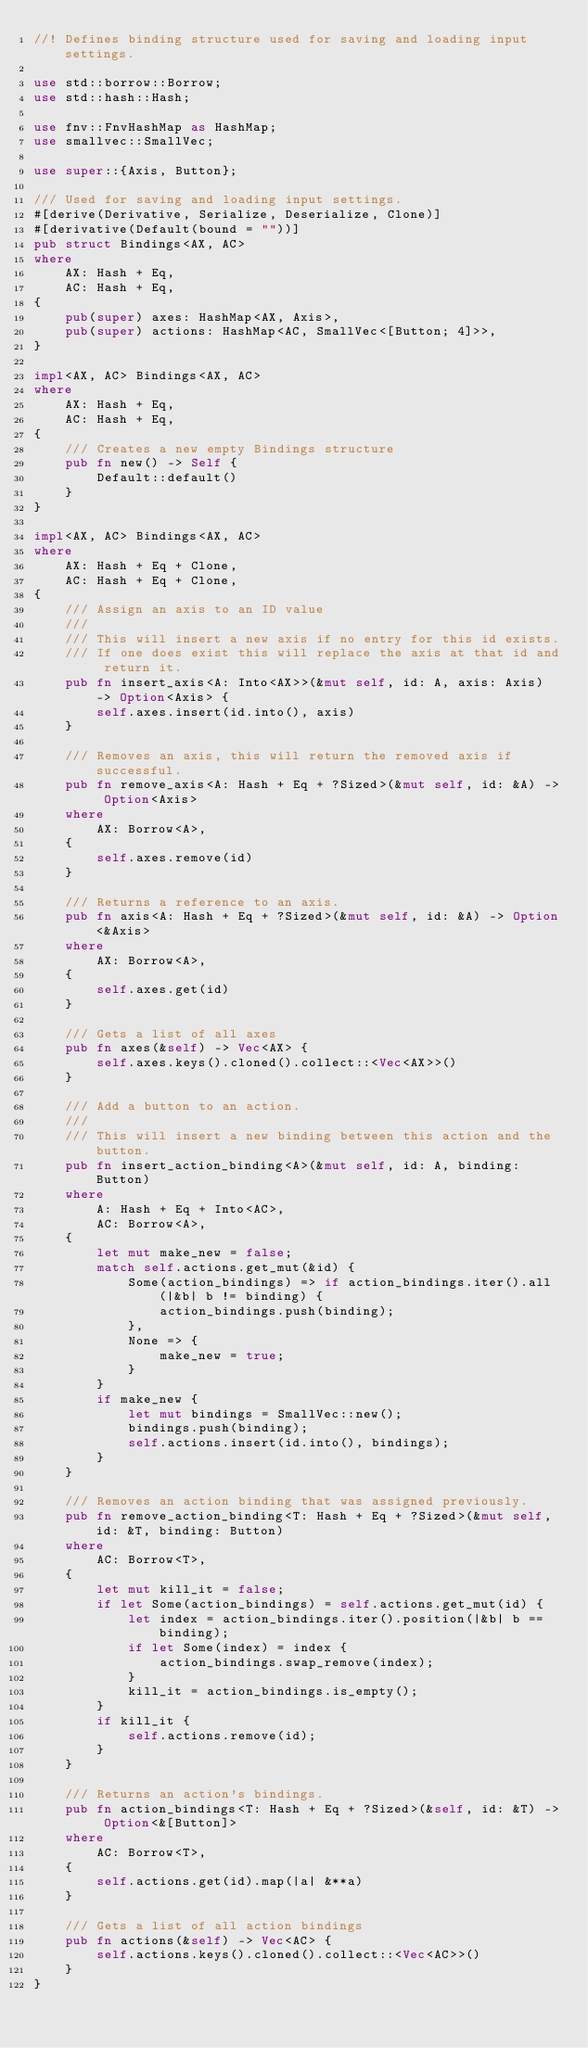Convert code to text. <code><loc_0><loc_0><loc_500><loc_500><_Rust_>//! Defines binding structure used for saving and loading input settings.

use std::borrow::Borrow;
use std::hash::Hash;

use fnv::FnvHashMap as HashMap;
use smallvec::SmallVec;

use super::{Axis, Button};

/// Used for saving and loading input settings.
#[derive(Derivative, Serialize, Deserialize, Clone)]
#[derivative(Default(bound = ""))]
pub struct Bindings<AX, AC>
where
    AX: Hash + Eq,
    AC: Hash + Eq,
{
    pub(super) axes: HashMap<AX, Axis>,
    pub(super) actions: HashMap<AC, SmallVec<[Button; 4]>>,
}

impl<AX, AC> Bindings<AX, AC>
where
    AX: Hash + Eq,
    AC: Hash + Eq,
{
    /// Creates a new empty Bindings structure
    pub fn new() -> Self {
        Default::default()
    }
}

impl<AX, AC> Bindings<AX, AC>
where
    AX: Hash + Eq + Clone,
    AC: Hash + Eq + Clone,
{
    /// Assign an axis to an ID value
    ///
    /// This will insert a new axis if no entry for this id exists.
    /// If one does exist this will replace the axis at that id and return it.
    pub fn insert_axis<A: Into<AX>>(&mut self, id: A, axis: Axis) -> Option<Axis> {
        self.axes.insert(id.into(), axis)
    }

    /// Removes an axis, this will return the removed axis if successful.
    pub fn remove_axis<A: Hash + Eq + ?Sized>(&mut self, id: &A) -> Option<Axis>
    where
        AX: Borrow<A>,
    {
        self.axes.remove(id)
    }

    /// Returns a reference to an axis.
    pub fn axis<A: Hash + Eq + ?Sized>(&mut self, id: &A) -> Option<&Axis>
    where
        AX: Borrow<A>,
    {
        self.axes.get(id)
    }

    /// Gets a list of all axes
    pub fn axes(&self) -> Vec<AX> {
        self.axes.keys().cloned().collect::<Vec<AX>>()
    }

    /// Add a button to an action.
    ///
    /// This will insert a new binding between this action and the button.
    pub fn insert_action_binding<A>(&mut self, id: A, binding: Button)
    where
        A: Hash + Eq + Into<AC>,
        AC: Borrow<A>,
    {
        let mut make_new = false;
        match self.actions.get_mut(&id) {
            Some(action_bindings) => if action_bindings.iter().all(|&b| b != binding) {
                action_bindings.push(binding);
            },
            None => {
                make_new = true;
            }
        }
        if make_new {
            let mut bindings = SmallVec::new();
            bindings.push(binding);
            self.actions.insert(id.into(), bindings);
        }
    }

    /// Removes an action binding that was assigned previously.
    pub fn remove_action_binding<T: Hash + Eq + ?Sized>(&mut self, id: &T, binding: Button)
    where
        AC: Borrow<T>,
    {
        let mut kill_it = false;
        if let Some(action_bindings) = self.actions.get_mut(id) {
            let index = action_bindings.iter().position(|&b| b == binding);
            if let Some(index) = index {
                action_bindings.swap_remove(index);
            }
            kill_it = action_bindings.is_empty();
        }
        if kill_it {
            self.actions.remove(id);
        }
    }

    /// Returns an action's bindings.
    pub fn action_bindings<T: Hash + Eq + ?Sized>(&self, id: &T) -> Option<&[Button]>
    where
        AC: Borrow<T>,
    {
        self.actions.get(id).map(|a| &**a)
    }

    /// Gets a list of all action bindings
    pub fn actions(&self) -> Vec<AC> {
        self.actions.keys().cloned().collect::<Vec<AC>>()
    }
}
</code> 